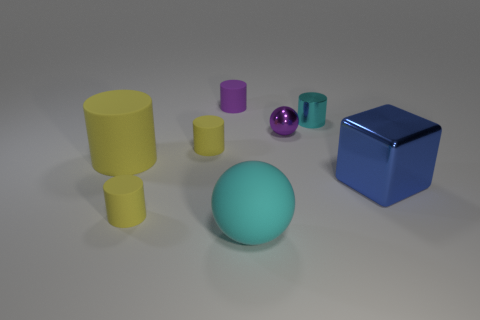Subtract all purple balls. How many yellow cylinders are left? 3 Subtract all purple cylinders. How many cylinders are left? 4 Subtract all purple matte cylinders. How many cylinders are left? 4 Subtract all red cylinders. Subtract all red spheres. How many cylinders are left? 5 Add 1 tiny yellow rubber cylinders. How many objects exist? 9 Subtract all cubes. How many objects are left? 7 Subtract all yellow objects. Subtract all rubber spheres. How many objects are left? 4 Add 4 purple things. How many purple things are left? 6 Add 1 blue metallic cubes. How many blue metallic cubes exist? 2 Subtract 0 yellow spheres. How many objects are left? 8 